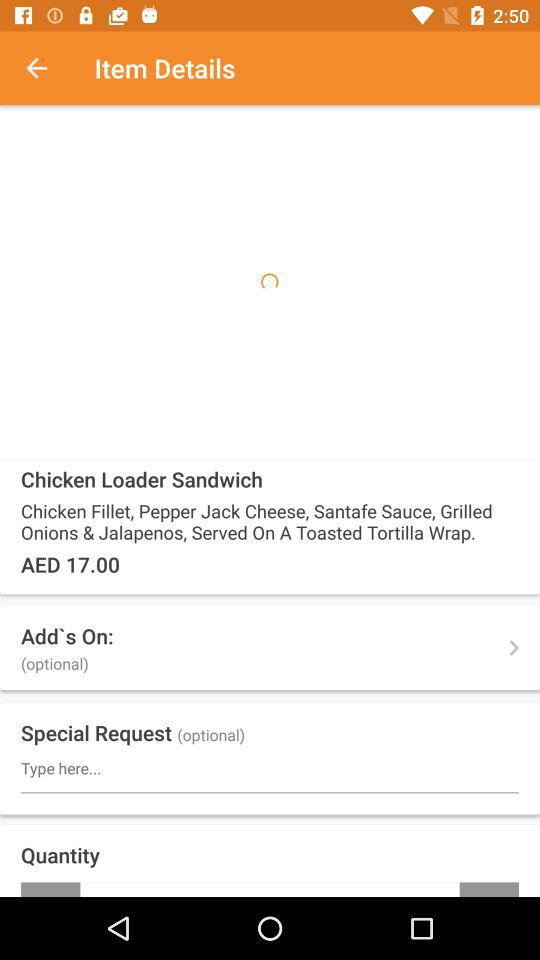What is the price of the sandwich? The price of the sandwich is AED 17.00. 